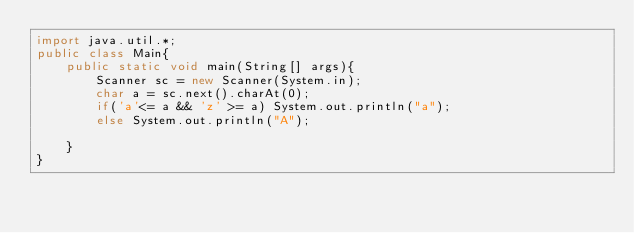<code> <loc_0><loc_0><loc_500><loc_500><_Java_>import java.util.*;
public class Main{
	public static void main(String[] args){
    	Scanner sc = new Scanner(System.in);
      	char a = sc.next().charAt(0);
      	if('a'<= a && 'z' >= a) System.out.println("a");
      	else System.out.println("A");
                                                   
    }
}</code> 